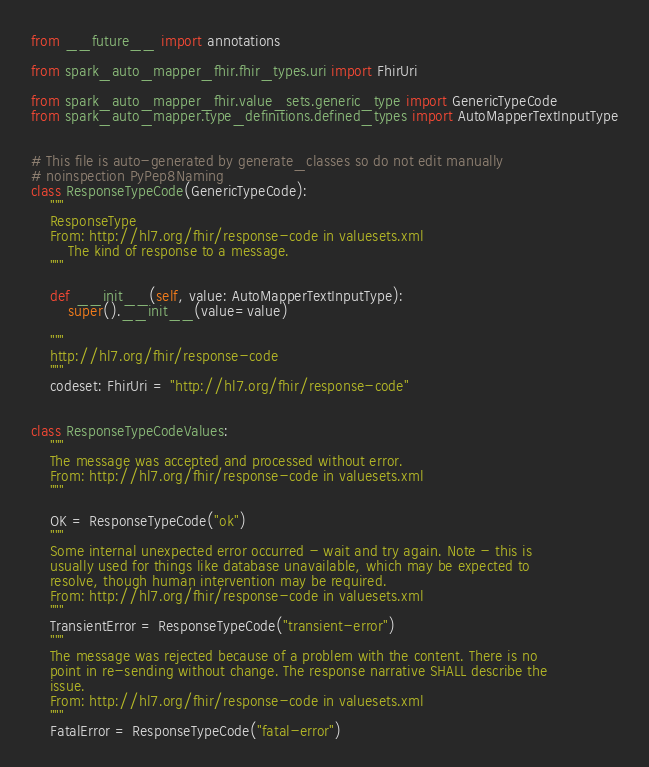Convert code to text. <code><loc_0><loc_0><loc_500><loc_500><_Python_>from __future__ import annotations

from spark_auto_mapper_fhir.fhir_types.uri import FhirUri

from spark_auto_mapper_fhir.value_sets.generic_type import GenericTypeCode
from spark_auto_mapper.type_definitions.defined_types import AutoMapperTextInputType


# This file is auto-generated by generate_classes so do not edit manually
# noinspection PyPep8Naming
class ResponseTypeCode(GenericTypeCode):
    """
    ResponseType
    From: http://hl7.org/fhir/response-code in valuesets.xml
        The kind of response to a message.
    """

    def __init__(self, value: AutoMapperTextInputType):
        super().__init__(value=value)

    """
    http://hl7.org/fhir/response-code
    """
    codeset: FhirUri = "http://hl7.org/fhir/response-code"


class ResponseTypeCodeValues:
    """
    The message was accepted and processed without error.
    From: http://hl7.org/fhir/response-code in valuesets.xml
    """

    OK = ResponseTypeCode("ok")
    """
    Some internal unexpected error occurred - wait and try again. Note - this is
    usually used for things like database unavailable, which may be expected to
    resolve, though human intervention may be required.
    From: http://hl7.org/fhir/response-code in valuesets.xml
    """
    TransientError = ResponseTypeCode("transient-error")
    """
    The message was rejected because of a problem with the content. There is no
    point in re-sending without change. The response narrative SHALL describe the
    issue.
    From: http://hl7.org/fhir/response-code in valuesets.xml
    """
    FatalError = ResponseTypeCode("fatal-error")
</code> 